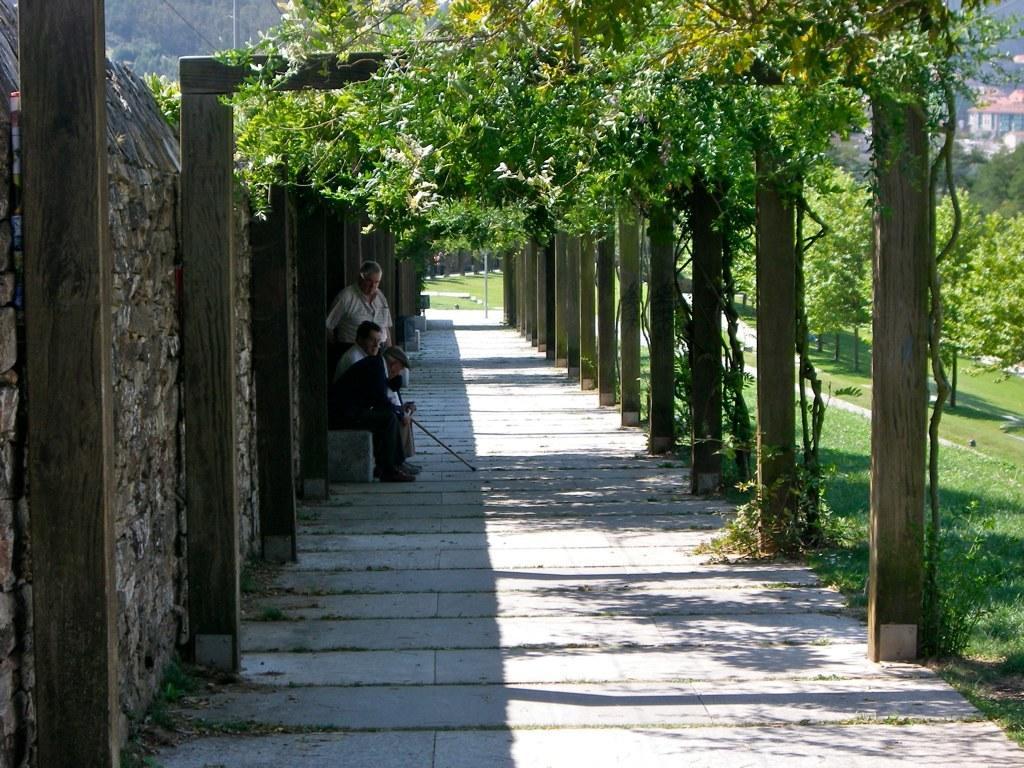Describe this image in one or two sentences. In this image I can see three people with different color dresses. I can see one person with the cap. In-front of these people I can see the poles and plants. To the left I can see the wall. In the background I can see the houses and the mountains. 